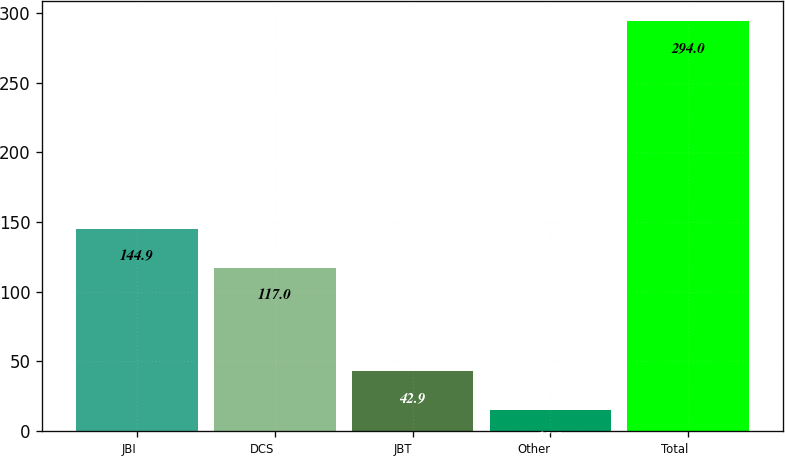Convert chart. <chart><loc_0><loc_0><loc_500><loc_500><bar_chart><fcel>JBI<fcel>DCS<fcel>JBT<fcel>Other<fcel>Total<nl><fcel>144.9<fcel>117<fcel>42.9<fcel>15<fcel>294<nl></chart> 